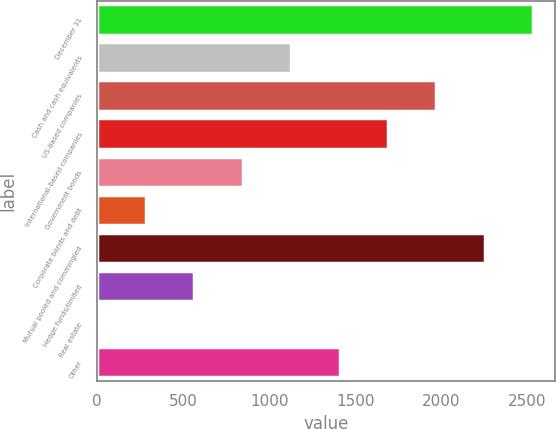Convert chart. <chart><loc_0><loc_0><loc_500><loc_500><bar_chart><fcel>December 31<fcel>Cash and cash equivalents<fcel>US-based companies<fcel>International-based companies<fcel>Government bonds<fcel>Corporate bonds and debt<fcel>Mutual pooled and commingled<fcel>Hedge funds/limited<fcel>Real estate<fcel>Other<nl><fcel>2533.7<fcel>1127.2<fcel>1971.1<fcel>1689.8<fcel>845.9<fcel>283.3<fcel>2252.4<fcel>564.6<fcel>2<fcel>1408.5<nl></chart> 